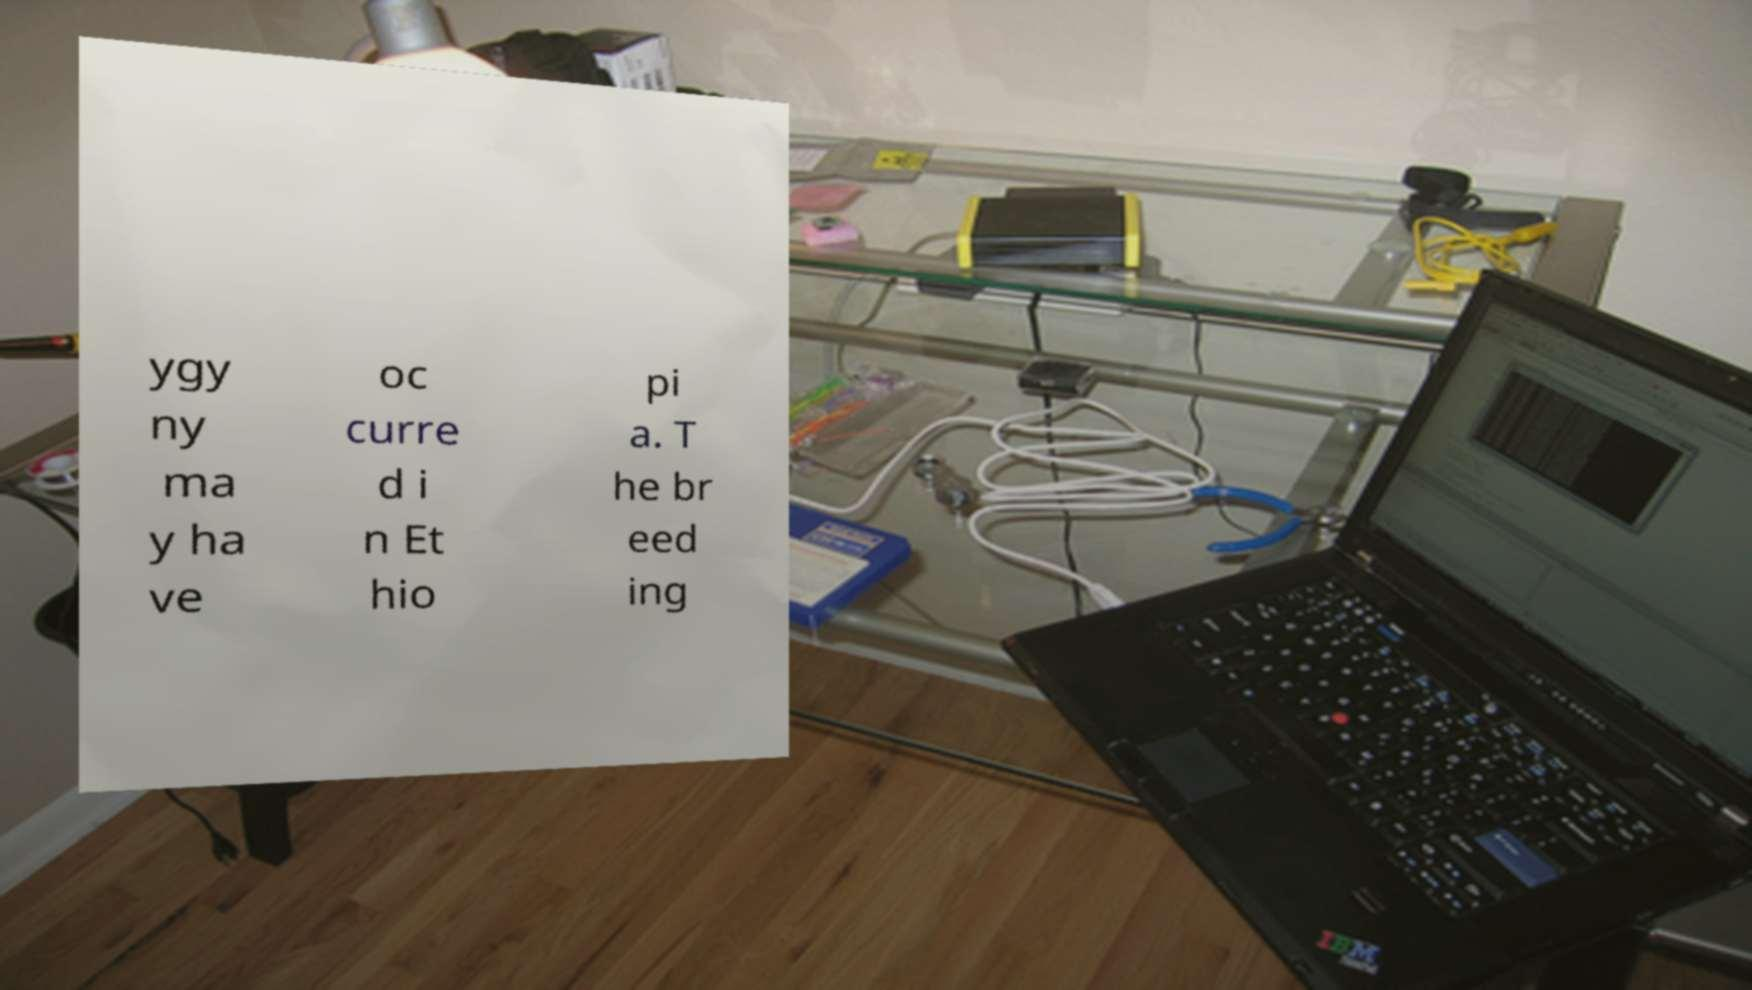Please read and relay the text visible in this image. What does it say? ygy ny ma y ha ve oc curre d i n Et hio pi a. T he br eed ing 